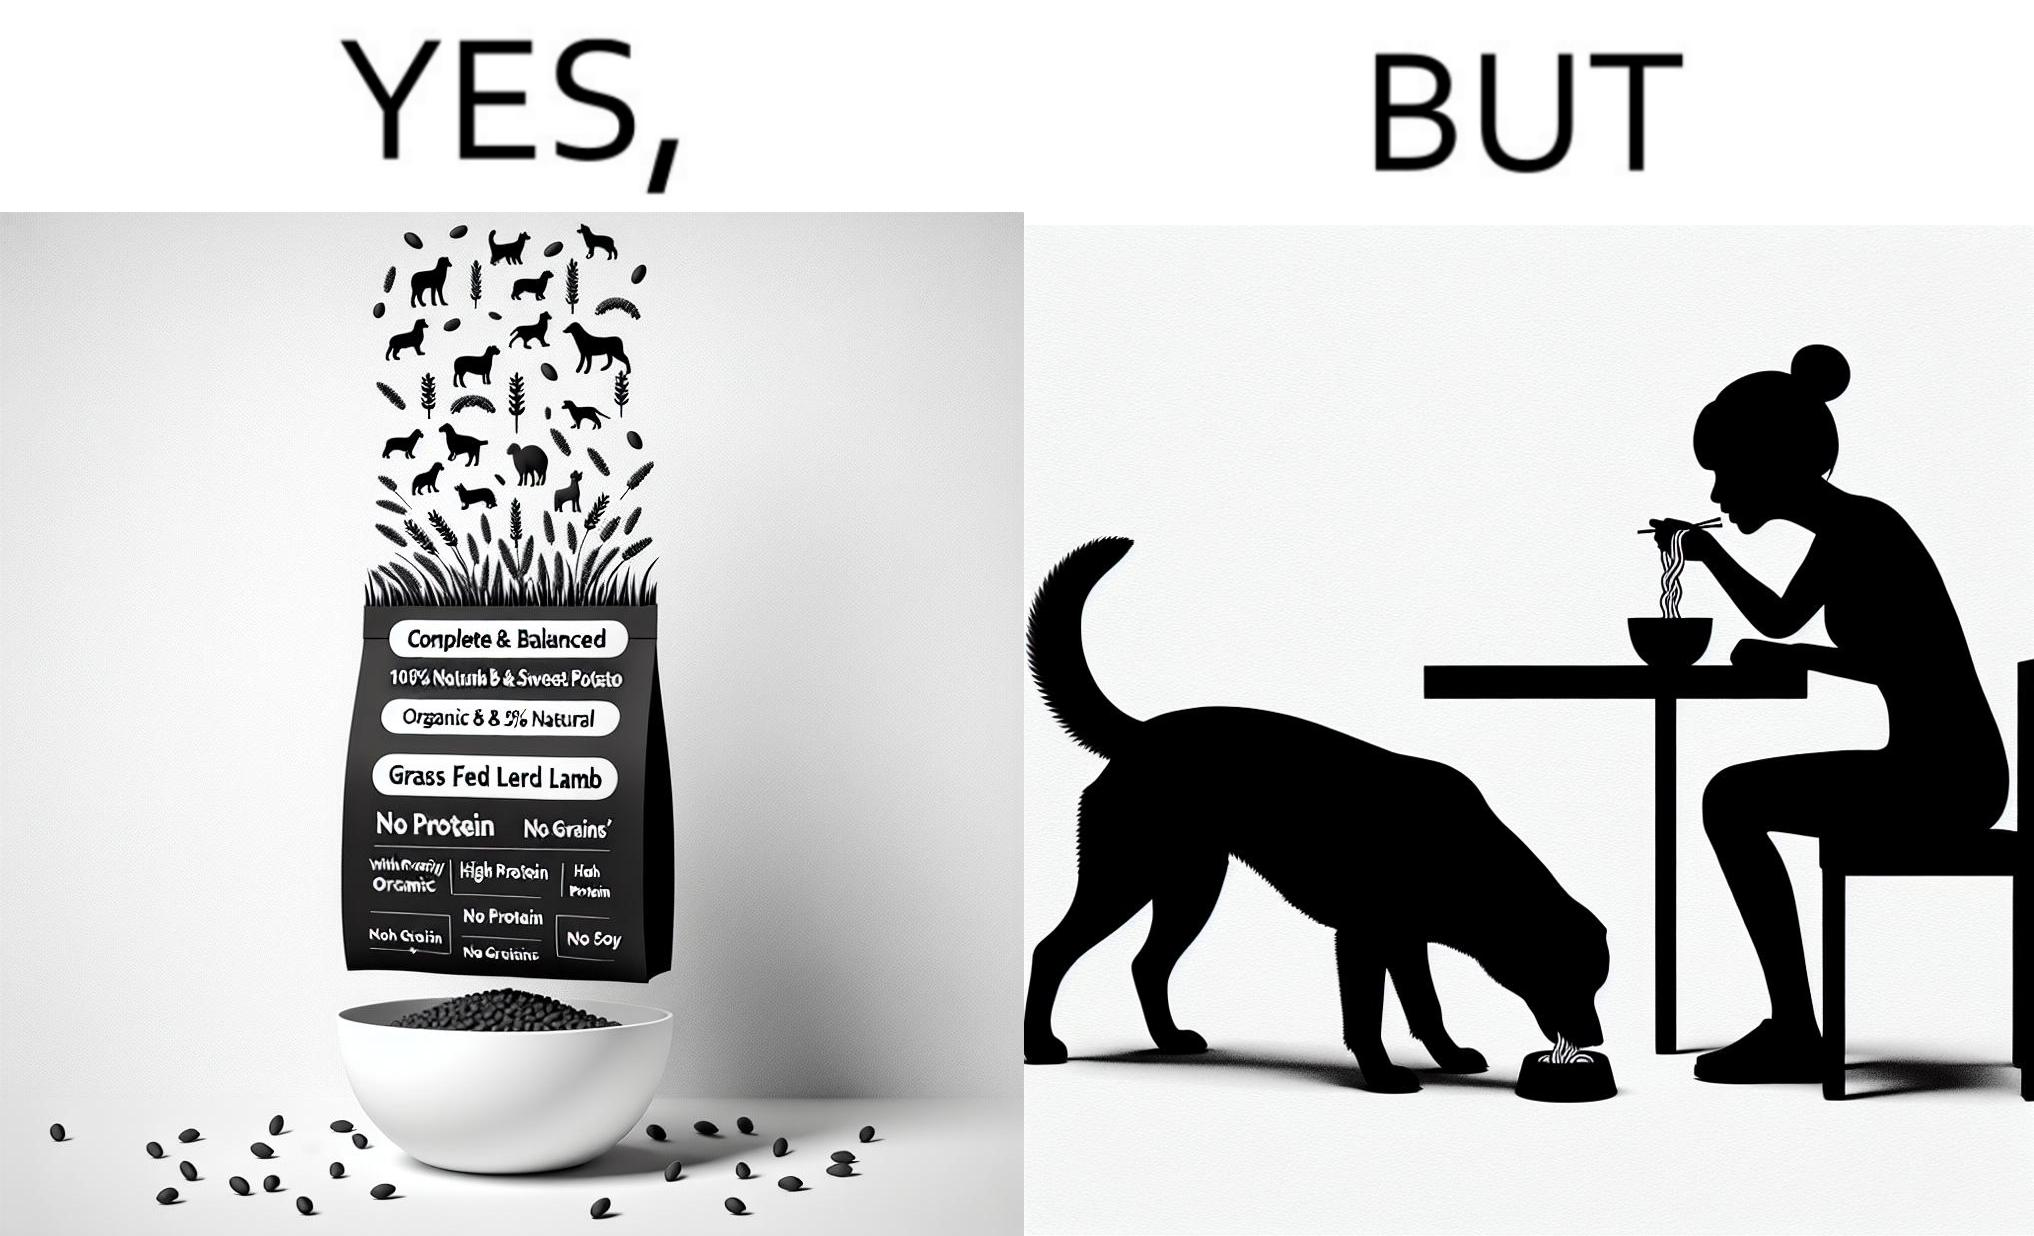Describe the contrast between the left and right parts of this image. In the left part of the image: The image shows food grains being poured into a bowl from the packet. The packet says "Complete & Balanced", "Organic", "100% Natural", "Grass Fed Lamb & Sweet Potato" , "With Prebiotic", "High Protein", "No grains", "No Gluten" and "No Soy". In the right part of the image: The image shows a dog eating food from its bowl on the floor and a woman eating noodles from a cup on the table. 